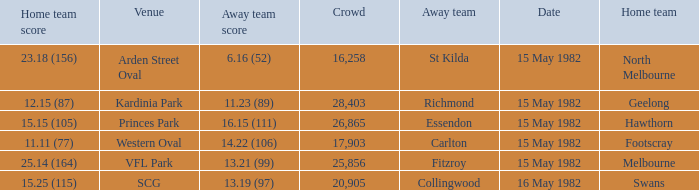What did the away team score when playing Footscray? 14.22 (106). 